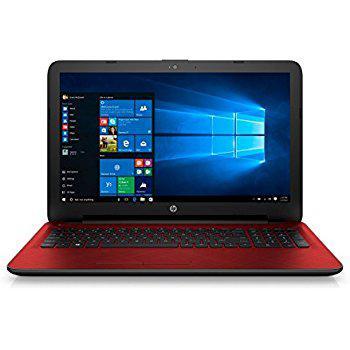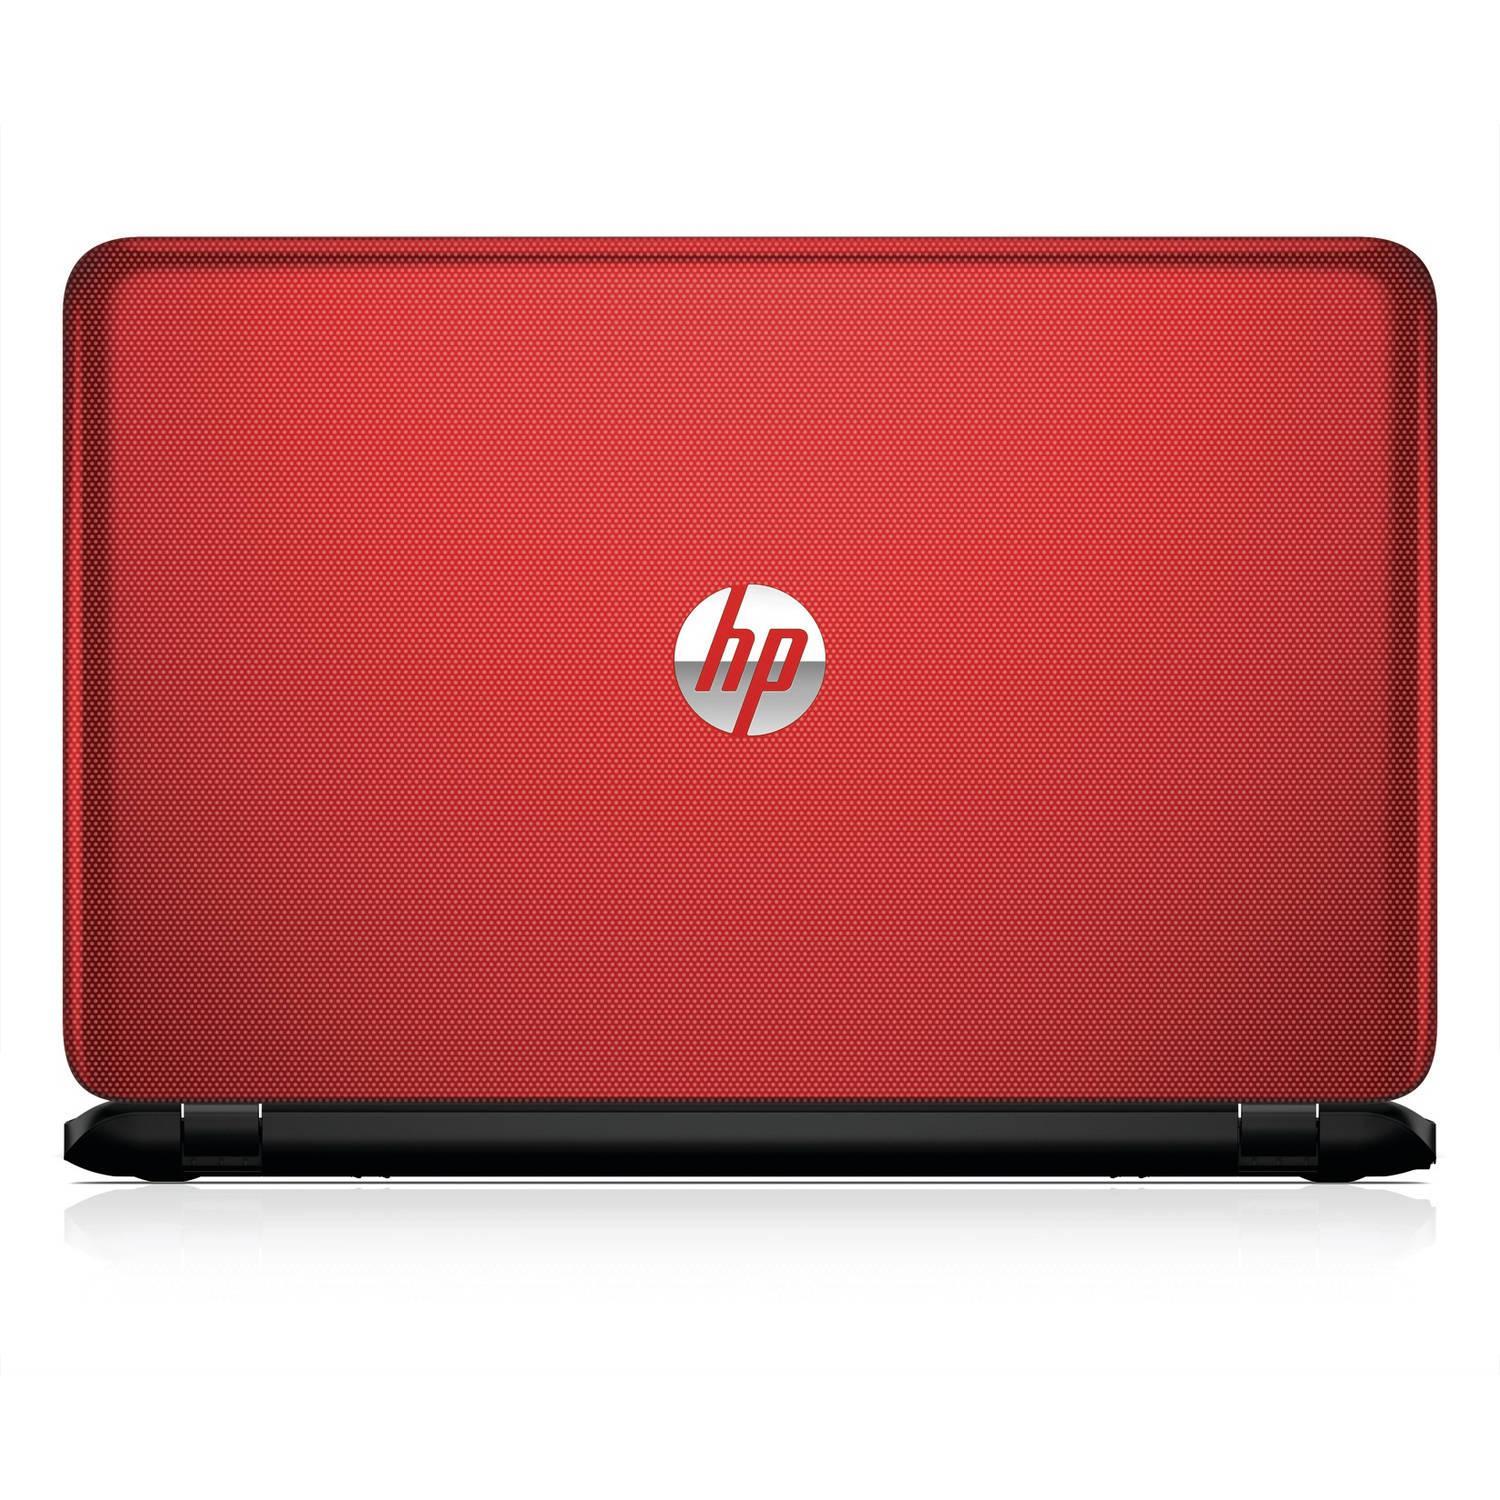The first image is the image on the left, the second image is the image on the right. Considering the images on both sides, is "One of the laptops is turned so the screen is visible, and the other is turned so that the screen is not visible." valid? Answer yes or no. Yes. The first image is the image on the left, the second image is the image on the right. Considering the images on both sides, is "The full back of the red laptop is being shown." valid? Answer yes or no. Yes. 